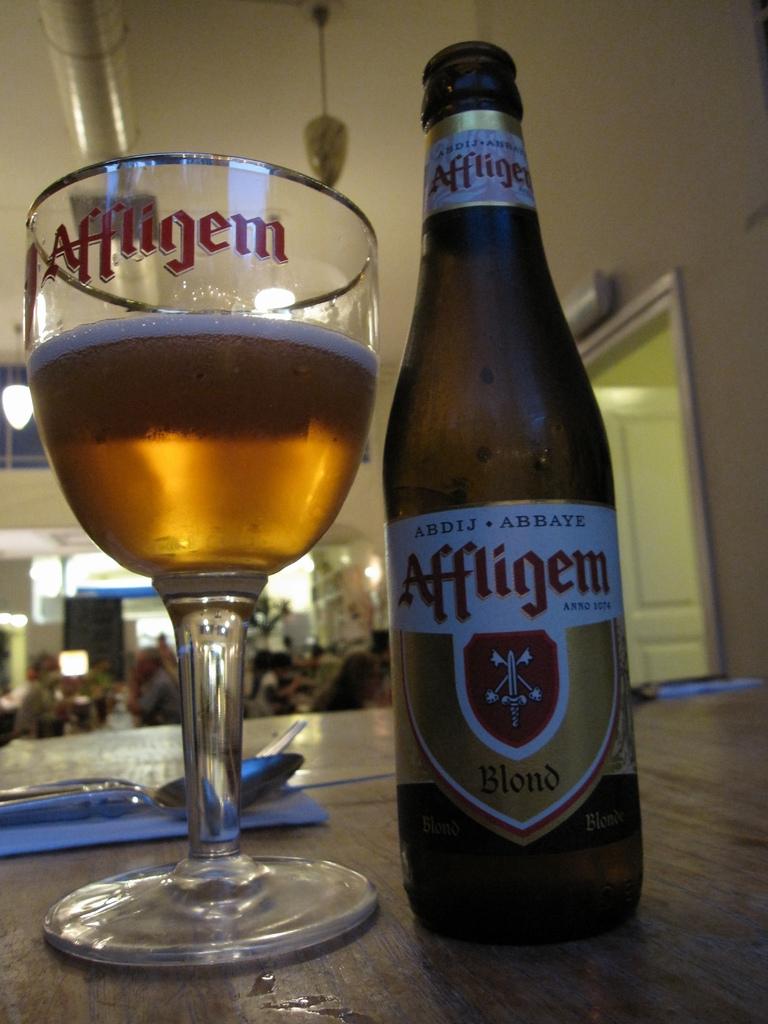What is the brand found on both the bottle and the cup?
Offer a terse response. Affligem. 